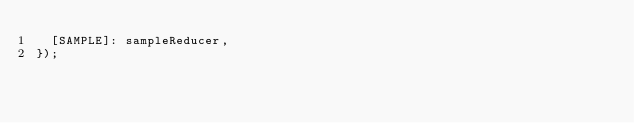<code> <loc_0><loc_0><loc_500><loc_500><_JavaScript_>  [SAMPLE]: sampleReducer,
});
</code> 